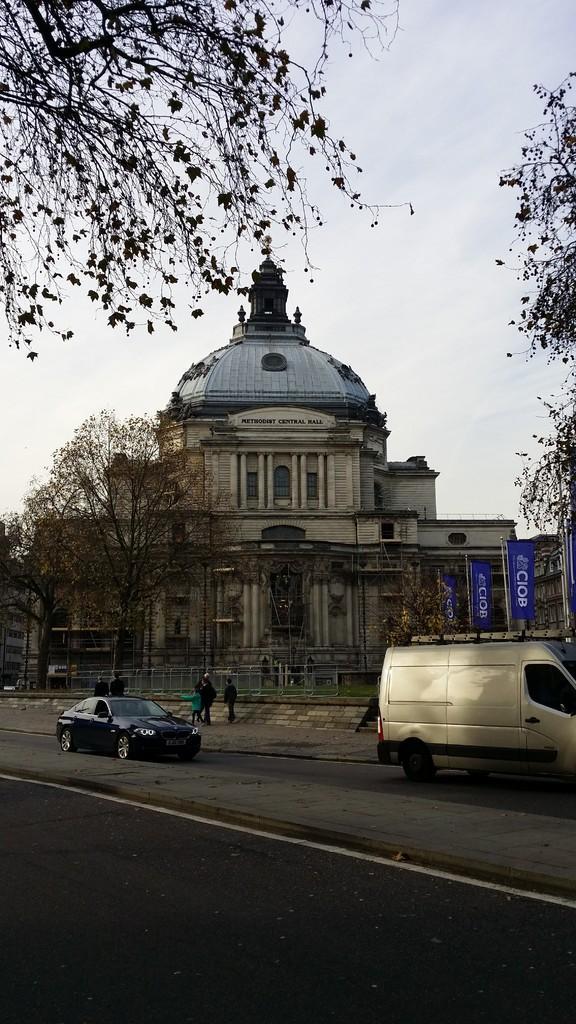Please provide a concise description of this image. To the bottom of the image there is a road. Behind the road there is a divider. Behind the divider there is a road. On the road there is a car and a van on it. Behind them there few people and also there is a fencing. Behind the fencing there are trees and also there is a building with pillars, walls and roof. And also there are poles with flags. To the top of the image there is a sky and also to the left top corner of the image there is a tree. 